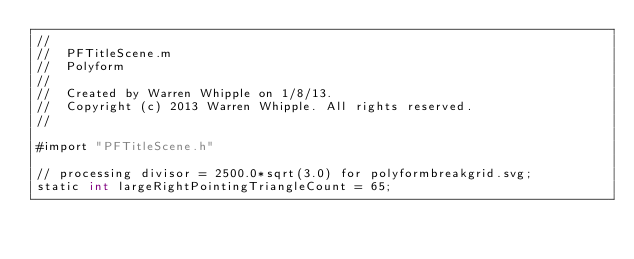Convert code to text. <code><loc_0><loc_0><loc_500><loc_500><_ObjectiveC_>//
//  PFTitleScene.m
//  Polyform
//
//  Created by Warren Whipple on 1/8/13.
//  Copyright (c) 2013 Warren Whipple. All rights reserved.
//

#import "PFTitleScene.h"

// processing divisor = 2500.0*sqrt(3.0) for polyformbreakgrid.svg;
static int largeRightPointingTriangleCount = 65;</code> 